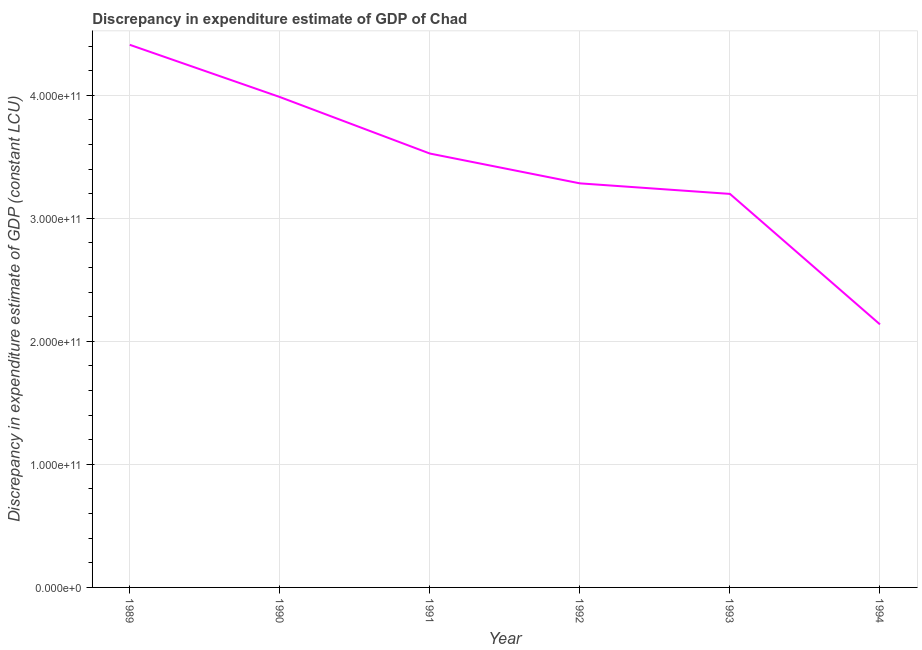What is the discrepancy in expenditure estimate of gdp in 1994?
Provide a succinct answer. 2.14e+11. Across all years, what is the maximum discrepancy in expenditure estimate of gdp?
Provide a short and direct response. 4.41e+11. Across all years, what is the minimum discrepancy in expenditure estimate of gdp?
Provide a short and direct response. 2.14e+11. In which year was the discrepancy in expenditure estimate of gdp maximum?
Offer a terse response. 1989. In which year was the discrepancy in expenditure estimate of gdp minimum?
Ensure brevity in your answer.  1994. What is the sum of the discrepancy in expenditure estimate of gdp?
Provide a short and direct response. 2.05e+12. What is the difference between the discrepancy in expenditure estimate of gdp in 1989 and 1994?
Offer a terse response. 2.27e+11. What is the average discrepancy in expenditure estimate of gdp per year?
Your response must be concise. 3.42e+11. What is the median discrepancy in expenditure estimate of gdp?
Provide a short and direct response. 3.41e+11. Do a majority of the years between 1993 and 1992 (inclusive) have discrepancy in expenditure estimate of gdp greater than 40000000000 LCU?
Your answer should be compact. No. What is the ratio of the discrepancy in expenditure estimate of gdp in 1992 to that in 1994?
Provide a short and direct response. 1.54. Is the discrepancy in expenditure estimate of gdp in 1993 less than that in 1994?
Your answer should be compact. No. Is the difference between the discrepancy in expenditure estimate of gdp in 1991 and 1993 greater than the difference between any two years?
Your answer should be very brief. No. What is the difference between the highest and the second highest discrepancy in expenditure estimate of gdp?
Ensure brevity in your answer.  4.24e+1. Is the sum of the discrepancy in expenditure estimate of gdp in 1990 and 1992 greater than the maximum discrepancy in expenditure estimate of gdp across all years?
Offer a terse response. Yes. What is the difference between the highest and the lowest discrepancy in expenditure estimate of gdp?
Offer a terse response. 2.27e+11. In how many years, is the discrepancy in expenditure estimate of gdp greater than the average discrepancy in expenditure estimate of gdp taken over all years?
Offer a very short reply. 3. What is the difference between two consecutive major ticks on the Y-axis?
Ensure brevity in your answer.  1.00e+11. Are the values on the major ticks of Y-axis written in scientific E-notation?
Your response must be concise. Yes. Does the graph contain grids?
Give a very brief answer. Yes. What is the title of the graph?
Offer a terse response. Discrepancy in expenditure estimate of GDP of Chad. What is the label or title of the Y-axis?
Offer a very short reply. Discrepancy in expenditure estimate of GDP (constant LCU). What is the Discrepancy in expenditure estimate of GDP (constant LCU) in 1989?
Your answer should be very brief. 4.41e+11. What is the Discrepancy in expenditure estimate of GDP (constant LCU) of 1990?
Offer a terse response. 3.99e+11. What is the Discrepancy in expenditure estimate of GDP (constant LCU) in 1991?
Keep it short and to the point. 3.53e+11. What is the Discrepancy in expenditure estimate of GDP (constant LCU) of 1992?
Offer a terse response. 3.28e+11. What is the Discrepancy in expenditure estimate of GDP (constant LCU) in 1993?
Your answer should be very brief. 3.20e+11. What is the Discrepancy in expenditure estimate of GDP (constant LCU) in 1994?
Ensure brevity in your answer.  2.14e+11. What is the difference between the Discrepancy in expenditure estimate of GDP (constant LCU) in 1989 and 1990?
Make the answer very short. 4.24e+1. What is the difference between the Discrepancy in expenditure estimate of GDP (constant LCU) in 1989 and 1991?
Your response must be concise. 8.84e+1. What is the difference between the Discrepancy in expenditure estimate of GDP (constant LCU) in 1989 and 1992?
Ensure brevity in your answer.  1.13e+11. What is the difference between the Discrepancy in expenditure estimate of GDP (constant LCU) in 1989 and 1993?
Provide a succinct answer. 1.21e+11. What is the difference between the Discrepancy in expenditure estimate of GDP (constant LCU) in 1989 and 1994?
Make the answer very short. 2.27e+11. What is the difference between the Discrepancy in expenditure estimate of GDP (constant LCU) in 1990 and 1991?
Your answer should be very brief. 4.59e+1. What is the difference between the Discrepancy in expenditure estimate of GDP (constant LCU) in 1990 and 1992?
Ensure brevity in your answer.  7.02e+1. What is the difference between the Discrepancy in expenditure estimate of GDP (constant LCU) in 1990 and 1993?
Your answer should be compact. 7.87e+1. What is the difference between the Discrepancy in expenditure estimate of GDP (constant LCU) in 1990 and 1994?
Your response must be concise. 1.85e+11. What is the difference between the Discrepancy in expenditure estimate of GDP (constant LCU) in 1991 and 1992?
Provide a short and direct response. 2.42e+1. What is the difference between the Discrepancy in expenditure estimate of GDP (constant LCU) in 1991 and 1993?
Offer a terse response. 3.28e+1. What is the difference between the Discrepancy in expenditure estimate of GDP (constant LCU) in 1991 and 1994?
Your answer should be very brief. 1.39e+11. What is the difference between the Discrepancy in expenditure estimate of GDP (constant LCU) in 1992 and 1993?
Provide a short and direct response. 8.57e+09. What is the difference between the Discrepancy in expenditure estimate of GDP (constant LCU) in 1992 and 1994?
Your response must be concise. 1.15e+11. What is the difference between the Discrepancy in expenditure estimate of GDP (constant LCU) in 1993 and 1994?
Provide a succinct answer. 1.06e+11. What is the ratio of the Discrepancy in expenditure estimate of GDP (constant LCU) in 1989 to that in 1990?
Ensure brevity in your answer.  1.11. What is the ratio of the Discrepancy in expenditure estimate of GDP (constant LCU) in 1989 to that in 1991?
Make the answer very short. 1.25. What is the ratio of the Discrepancy in expenditure estimate of GDP (constant LCU) in 1989 to that in 1992?
Ensure brevity in your answer.  1.34. What is the ratio of the Discrepancy in expenditure estimate of GDP (constant LCU) in 1989 to that in 1993?
Your response must be concise. 1.38. What is the ratio of the Discrepancy in expenditure estimate of GDP (constant LCU) in 1989 to that in 1994?
Your answer should be very brief. 2.06. What is the ratio of the Discrepancy in expenditure estimate of GDP (constant LCU) in 1990 to that in 1991?
Make the answer very short. 1.13. What is the ratio of the Discrepancy in expenditure estimate of GDP (constant LCU) in 1990 to that in 1992?
Ensure brevity in your answer.  1.21. What is the ratio of the Discrepancy in expenditure estimate of GDP (constant LCU) in 1990 to that in 1993?
Ensure brevity in your answer.  1.25. What is the ratio of the Discrepancy in expenditure estimate of GDP (constant LCU) in 1990 to that in 1994?
Your response must be concise. 1.86. What is the ratio of the Discrepancy in expenditure estimate of GDP (constant LCU) in 1991 to that in 1992?
Offer a very short reply. 1.07. What is the ratio of the Discrepancy in expenditure estimate of GDP (constant LCU) in 1991 to that in 1993?
Offer a terse response. 1.1. What is the ratio of the Discrepancy in expenditure estimate of GDP (constant LCU) in 1991 to that in 1994?
Provide a succinct answer. 1.65. What is the ratio of the Discrepancy in expenditure estimate of GDP (constant LCU) in 1992 to that in 1993?
Offer a very short reply. 1.03. What is the ratio of the Discrepancy in expenditure estimate of GDP (constant LCU) in 1992 to that in 1994?
Your answer should be very brief. 1.54. What is the ratio of the Discrepancy in expenditure estimate of GDP (constant LCU) in 1993 to that in 1994?
Provide a succinct answer. 1.5. 